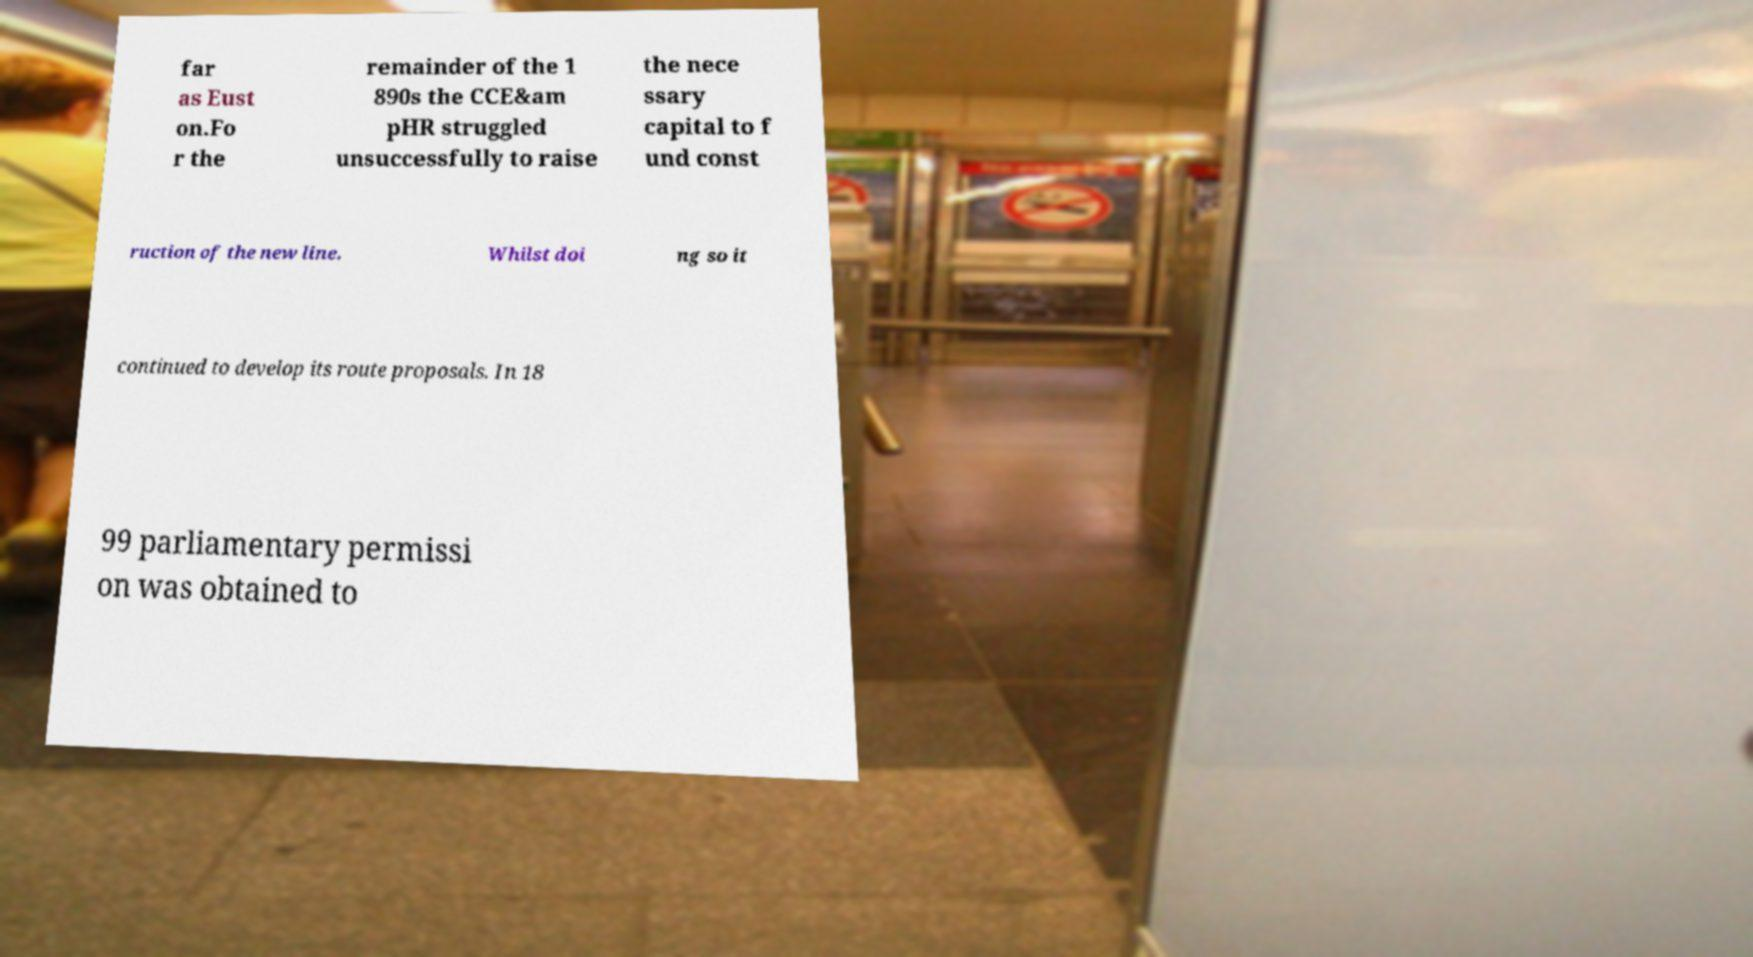Could you assist in decoding the text presented in this image and type it out clearly? far as Eust on.Fo r the remainder of the 1 890s the CCE&am pHR struggled unsuccessfully to raise the nece ssary capital to f und const ruction of the new line. Whilst doi ng so it continued to develop its route proposals. In 18 99 parliamentary permissi on was obtained to 